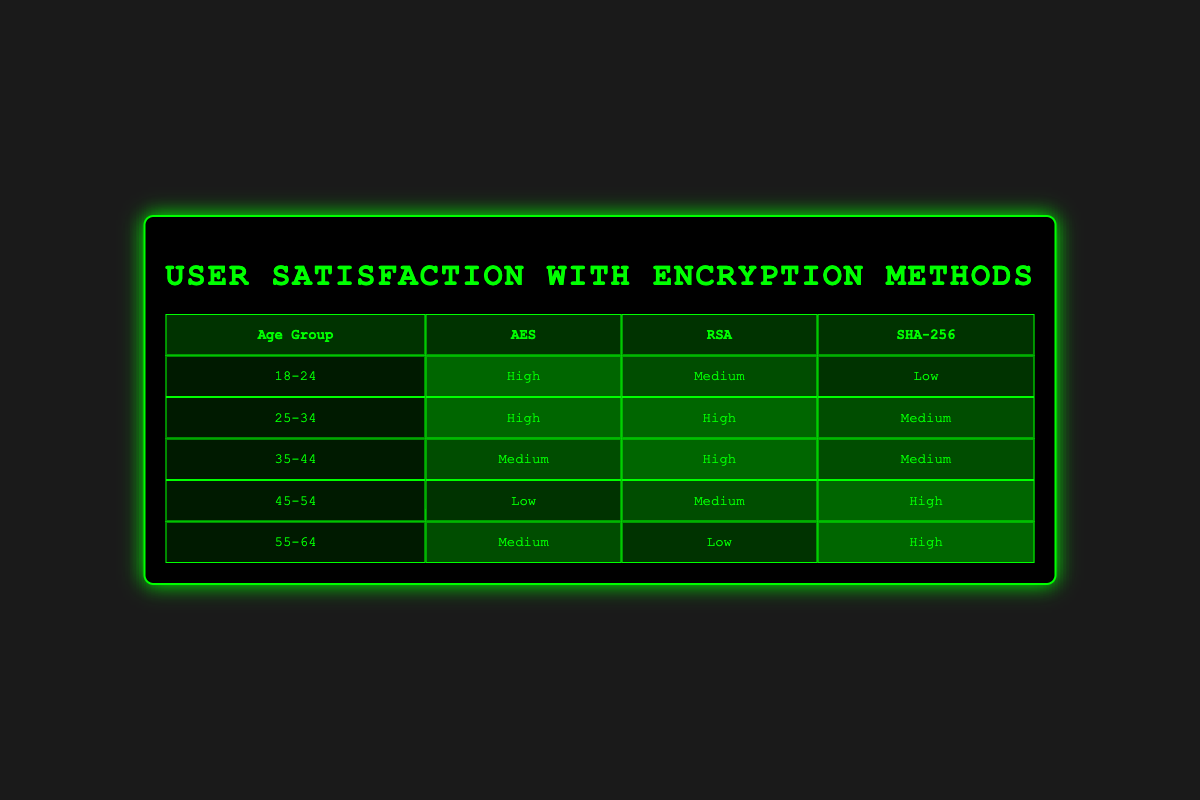What are the satisfaction levels for AES among the age group 45-54? According to the table, the satisfaction level for AES in the age group 45-54 is "Low."
Answer: Low Which age group has the highest satisfaction level for RSA? The age group 25-34 has the highest satisfaction level for RSA, which is classified as "High."
Answer: 25-34 Is there any age group that reported "Low" satisfaction with SHA-256? Yes, the age group 55-64 reported "Low" satisfaction with SHA-256.
Answer: Yes What is the average satisfaction level for the AES method across all age groups? The perceived satisfaction levels for AES are "High," "High," "Medium," "Low," and "Medium," corresponding to the age groups. Converting these into numerical values (High=3, Medium=2, Low=1), we have (3 + 3 + 2 + 1 + 2) = 11. Since there are five age groups, the average becomes 11/5 = 2.2, or Medium.
Answer: Medium Which encryption method has the highest overall satisfaction level? To find this, we assess the satisfaction levels for each method across all age groups: AES has 2 High, 2 Medium, 1 Low; RSA has 3 High, 1 Medium, 1 Low; and SHA-256 has 2 High, 3 Medium, 1 Low. RSA has the most "High" ratings (3), making it the encryption method with the highest overall satisfaction level.
Answer: RSA What percentage of the age group 18-24 rated AES as "High"? The age group 18-24 has a total of 3 satisfaction ratings, and 1 of those ratings is classified as "High" for AES. Therefore, to calculate the percentage, (1/3) * 100 = 33.33%.
Answer: 33.33% Is "High" the most common satisfaction level reported for the 35-44 age group? No, for the 35-44 age group, the reported satisfaction levels are "Medium" for AES, "High" for RSA, and "Medium" for SHA-256. Since "Medium" is not less than "High" but is the most frequent here, "High" is not the most common level.
Answer: No What is the difference in satisfaction levels for AES between age groups 25-34 and 45-54? For age group 25-34, AES satisfaction is "High," and for age group 45-54, it is "Low." Converting to numerical values (High=3, Low=1), the difference is 3 - 1 = 2.
Answer: 2 Which age group is the least satisfied with the AES method? Looking at all the entries for AES, age group 45-54 reported "Low" satisfaction, which is the lowest among the groups that rated this method.
Answer: 45-54 